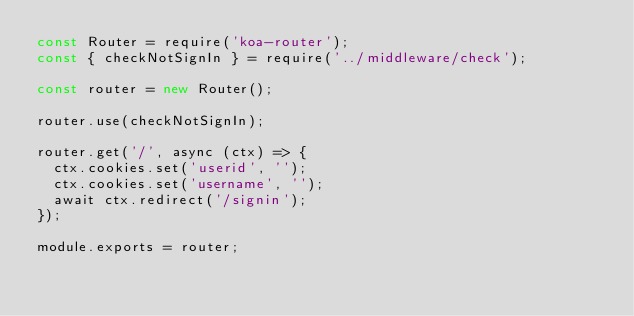<code> <loc_0><loc_0><loc_500><loc_500><_JavaScript_>const Router = require('koa-router');
const { checkNotSignIn } = require('../middleware/check');

const router = new Router();

router.use(checkNotSignIn);

router.get('/', async (ctx) => {
  ctx.cookies.set('userid', '');
  ctx.cookies.set('username', '');
  await ctx.redirect('/signin');
});

module.exports = router;
</code> 